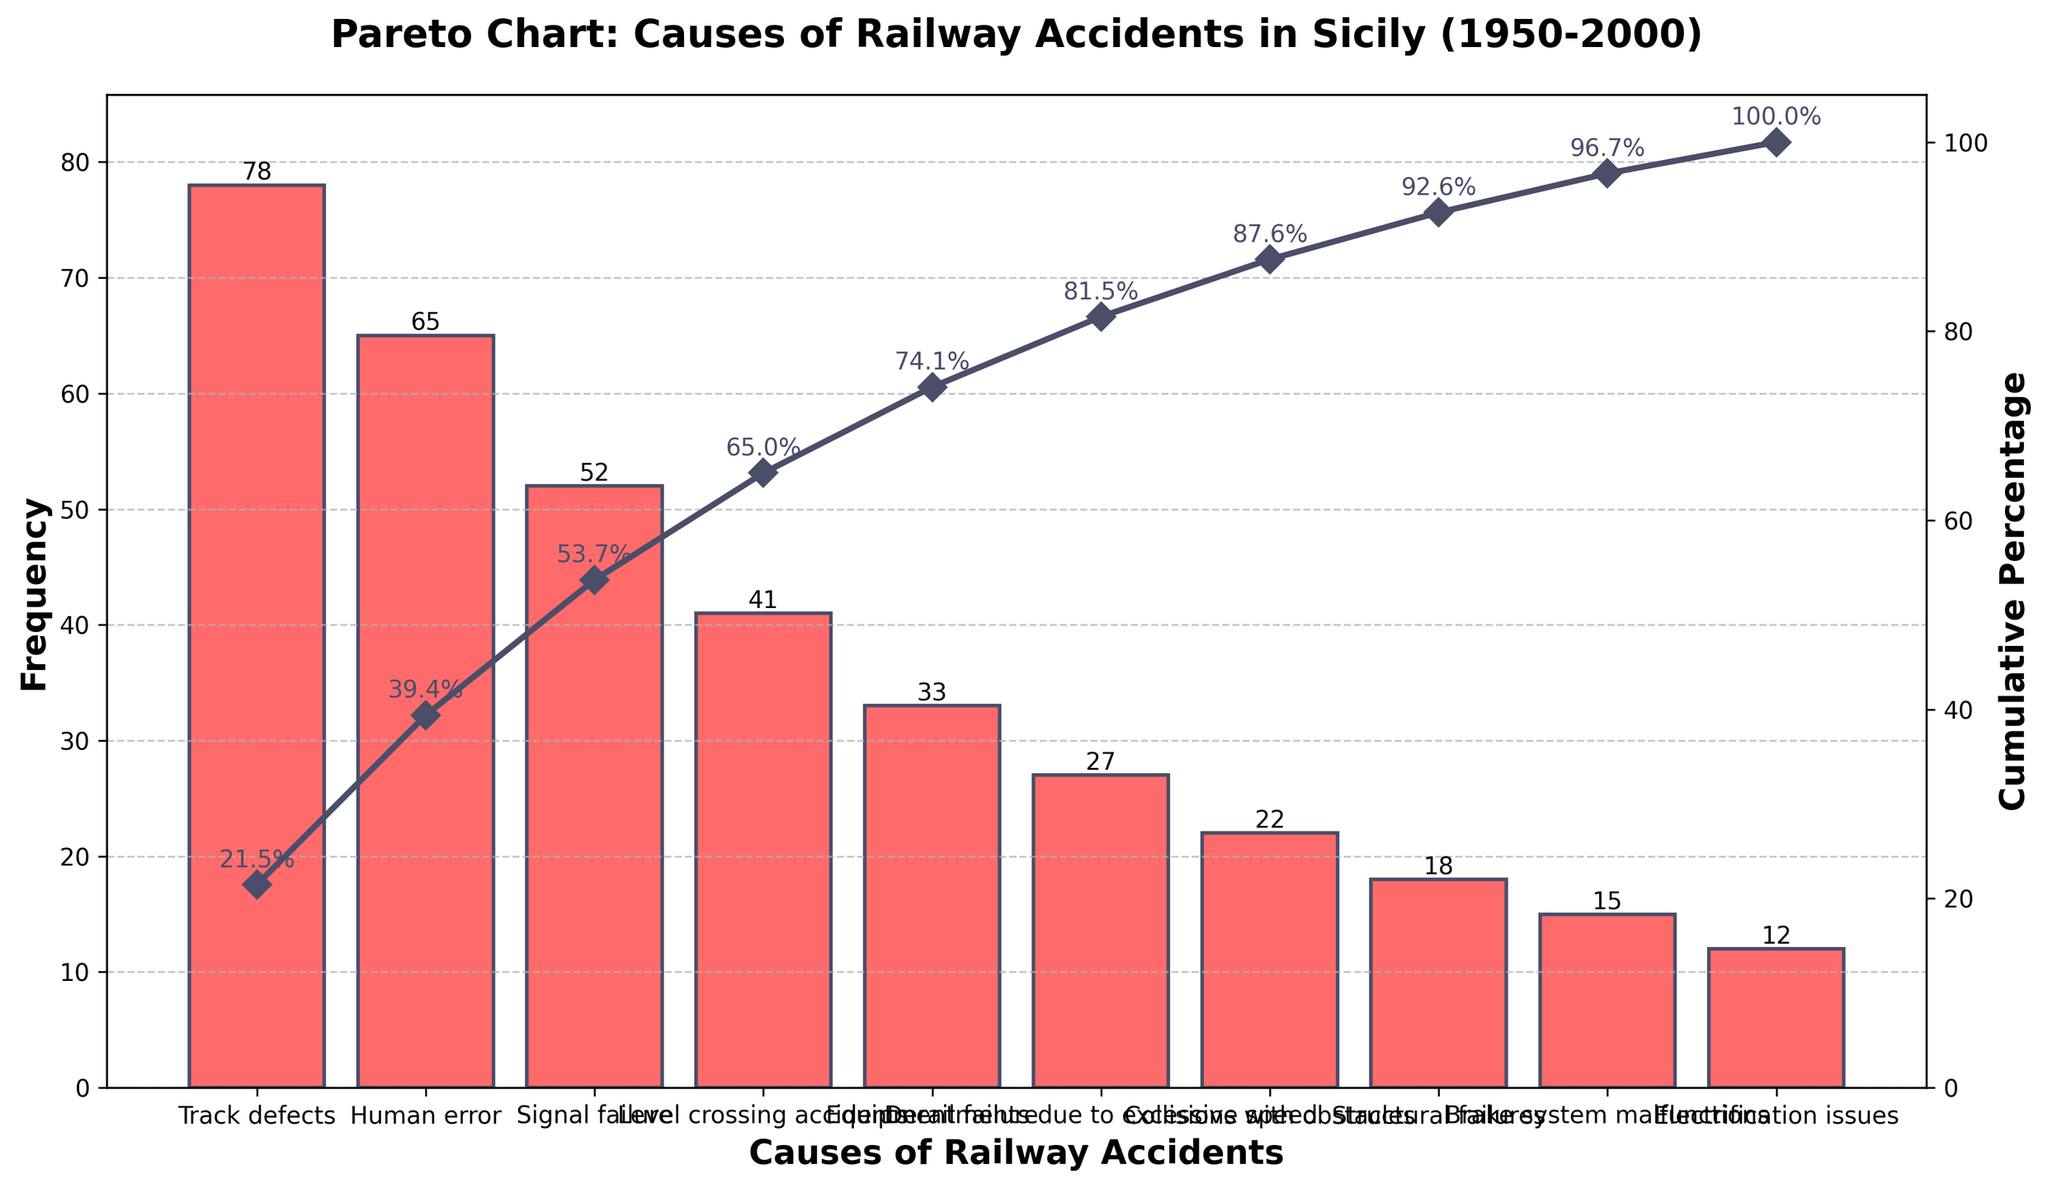What's the most frequent cause of railway accidents in Sicily? The bars in the Pareto chart represent the frequency of different causes of railway accidents. The tallest bar signifies the most frequent cause. Here, the "Track defects" bar is the tallest, indicating it is the most frequent.
Answer: Track defects How many total railway accidents occurred from 1950 to 2000 according to the data? To find the total number of accidents, sum the frequencies of all causes. Adding the values: 78 + 65 + 52 + 41 + 33 + 27 + 22 + 18 + 15 + 12 = 363.
Answer: 363 Which causes account for over 50% of the total accidents? The cumulative percentage line shows the cumulative contributions of each cause. Track defects, Human error, and Signal failure together surpass 50%, visible from the sharp rise in the cumulative percentage up to ~54%.
Answer: Track defects, Human error, Signal failure How does the frequency of "Equipment failure" compare to "Level crossing accidents"? Compare their bar heights or counts directly. "Level crossing accidents" has a frequency of 41 while "Equipment failure" has 33. Therefore, Level crossing accidents are more frequent.
Answer: Level crossing accidents are more frequent What is the cumulative percentage of "Human error"? Locate the point on the cumulative line above "Human error" and read the percentage directly or from the annotation. It is 39.4%.
Answer: 39.4% What's the difference in frequency between the most and least common causes? Subtract the frequency of the least common cause (Electrification issues, 12) from the most common cause (Track defects, 78): 78 - 12 = 66
Answer: 66 Which cause has a frequency of 27? Locate the bar with height 27 on the Pareto chart. The corresponding label is "Derailments due to excessive speed".
Answer: Derailments due to excessive speed How many causes have a frequency higher than 30? Count the number of bars with heights greater than 30. These are Track defects (78), Human error (65), Signal failure (52), Level crossing accidents (41), and Equipment failure (33). There are five causes.
Answer: 5 What percentage of accidents are accounted for by the first three causes? Sum the percentages for Track defects, Human error, and Signal failure from the cumulative percentage line: 21.5% + 39.4% - 21.5% (already included) + 54.6% - 39.4% = 54.6%.
Answer: 54.6% What is the mean frequency of all the causes listed? Sum all frequencies and divide by the number of causes. The total number, as calculated earlier, is 363. There are 10 causes. So, 363 / 10 = 36.3
Answer: 36.3 